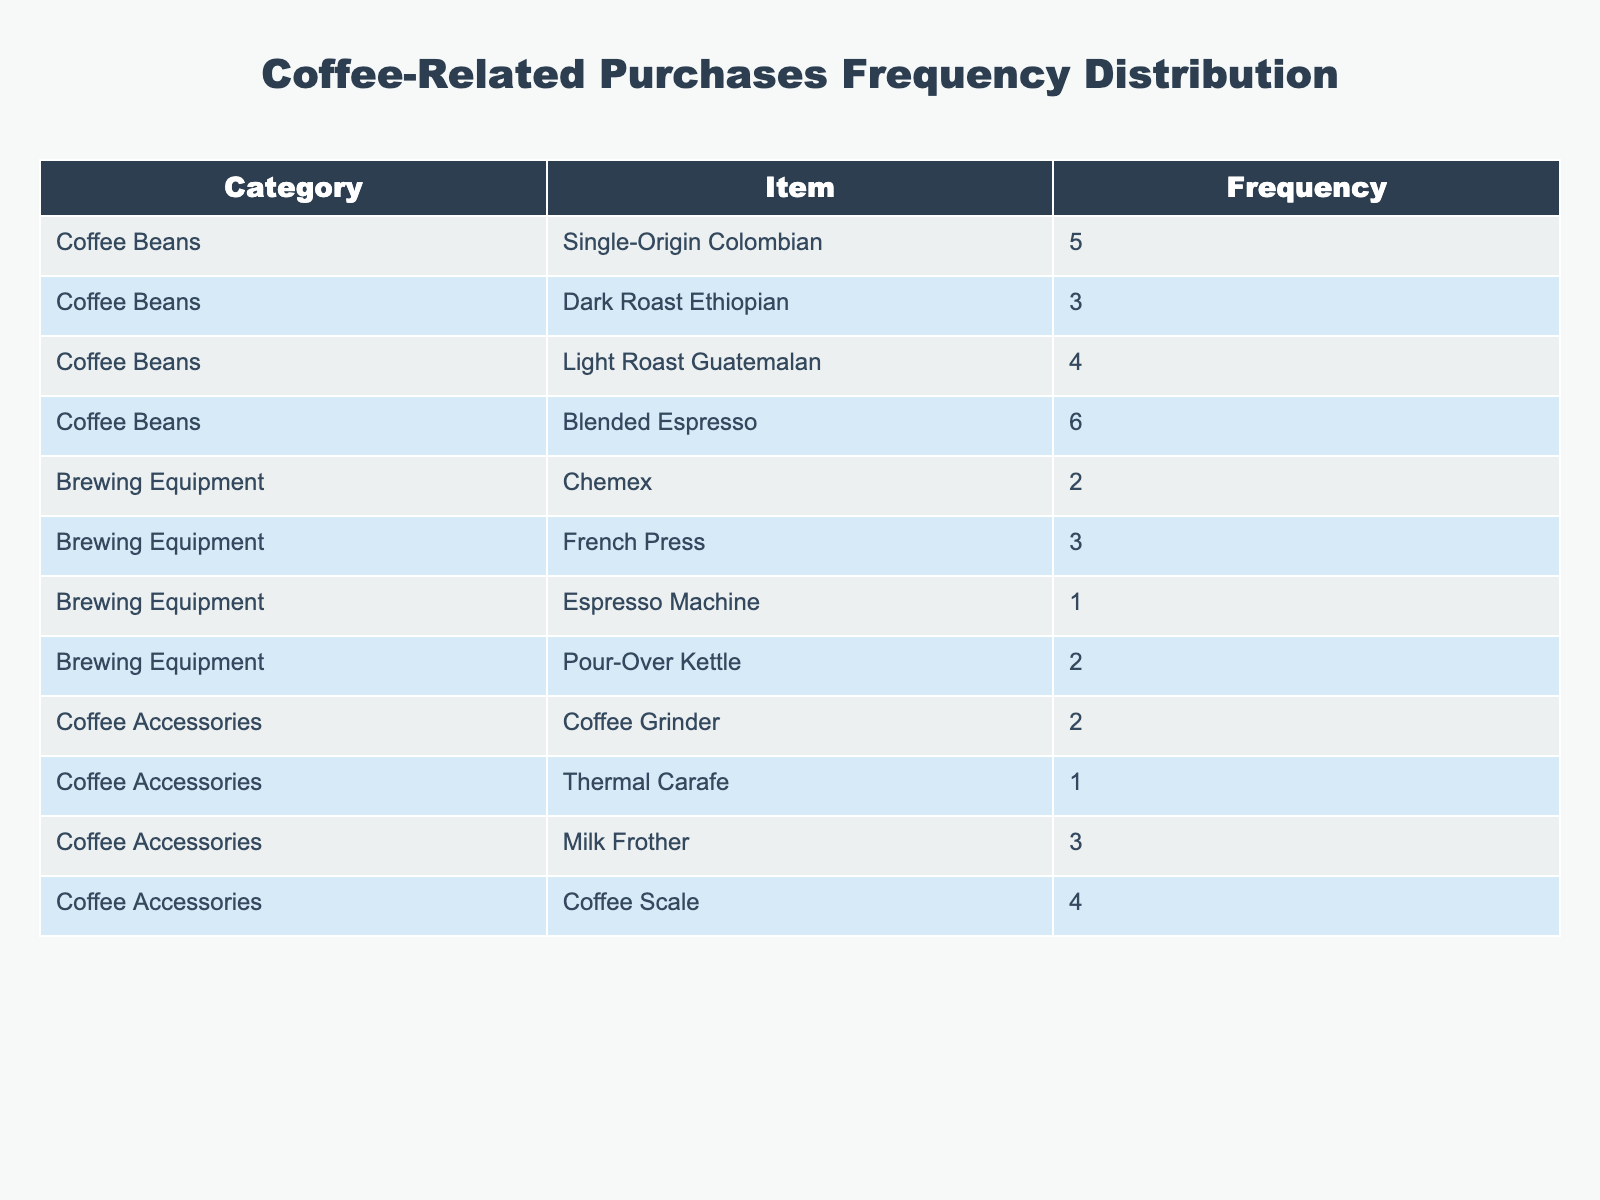What is the most frequently purchased coffee bean? The coffee bean with the highest frequency in the table is the Blended Espresso, which has a frequency of 6.
Answer: Blended Espresso How many times were Dark Roast Ethiopian beans purchased? The table shows that Dark Roast Ethiopian beans were purchased 3 times.
Answer: 3 Which category had the least purchases overall? By summing up the frequencies for each category: Coffee Beans (18), Brewing Equipment (8), Coffee Accessories (10). Since the Brewing Equipment category has the lowest total frequency of 8, it had the least purchases overall.
Answer: Brewing Equipment What is the total frequency of all coffee accessories purchased? Adding the frequencies of the Coffee Accessories: Coffee Grinder (2) + Thermal Carafe (1) + Milk Frother (3) + Coffee Scale (4) = 10.
Answer: 10 Is it true that more than 5 items of brewing equipment were purchased in total? The total frequency for Brewing Equipment is 8, which is not more than 5. Therefore, the statement is false.
Answer: No What is the average frequency of the coffee beans purchased? The total frequency for Coffee Beans is 18, divided by the 4 different types of beans gives an average of 18/4 = 4.5.
Answer: 4.5 Which item has an equal purchase frequency to the Thermal Carafe? The Thermal Carafe has a frequency of 1, and the Espresso Machine also has a frequency of 1, making these two items equal in purchase frequency.
Answer: Espresso Machine How many more purchases were made in coffee beans than in coffee accessories? Coffee Beans total 18 purchases and Coffee Accessories total 10. The difference is 18 - 10 = 8, meaning there were 8 more purchases in coffee beans.
Answer: 8 What percentage of total purchases came from Single-Origin Colombian beans? The total frequency of all purchases is 36. Single-Origin Colombian has a frequency of 5. Therefore, (5/36) x 100 = 13.89%.
Answer: 13.89% 